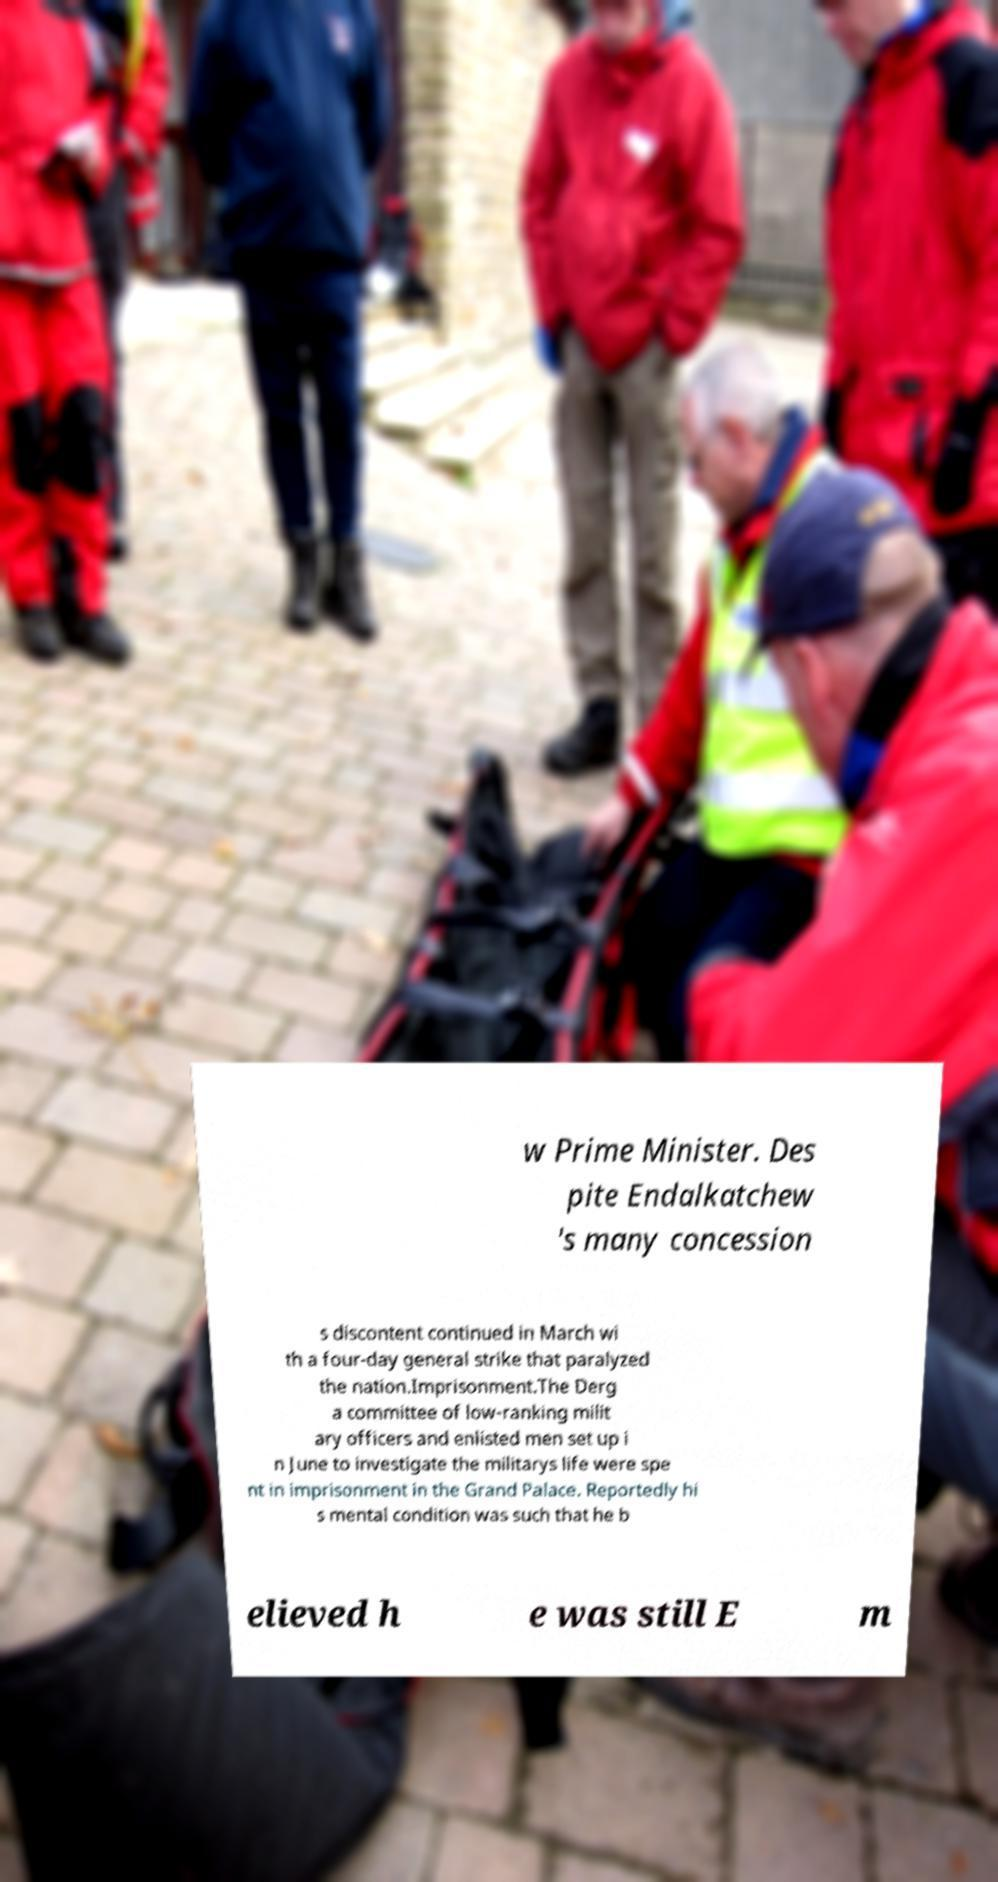There's text embedded in this image that I need extracted. Can you transcribe it verbatim? w Prime Minister. Des pite Endalkatchew 's many concession s discontent continued in March wi th a four-day general strike that paralyzed the nation.Imprisonment.The Derg a committee of low-ranking milit ary officers and enlisted men set up i n June to investigate the militarys life were spe nt in imprisonment in the Grand Palace. Reportedly hi s mental condition was such that he b elieved h e was still E m 